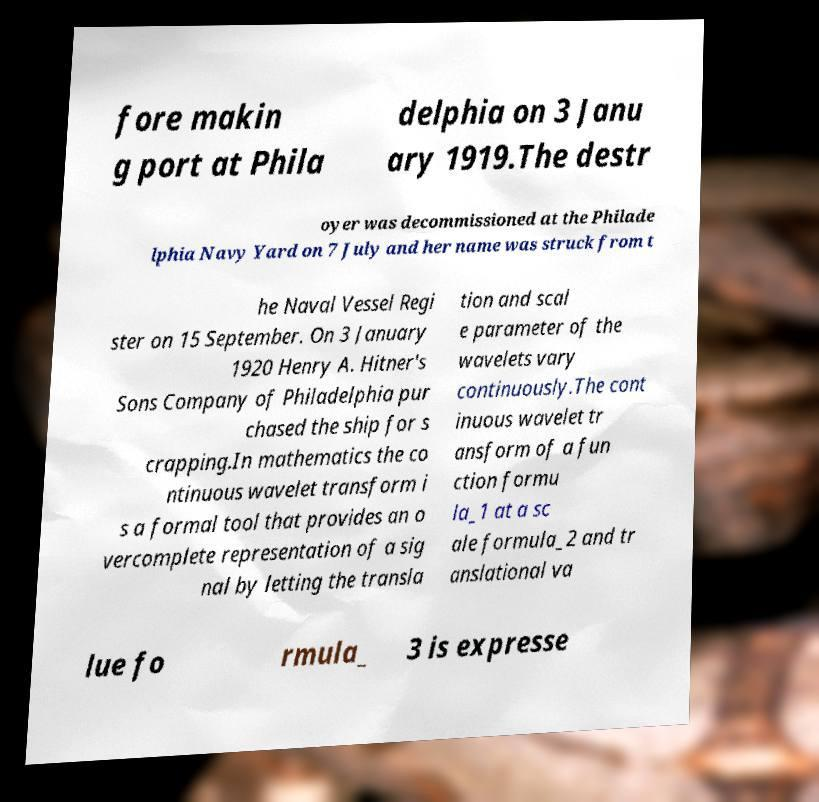What messages or text are displayed in this image? I need them in a readable, typed format. fore makin g port at Phila delphia on 3 Janu ary 1919.The destr oyer was decommissioned at the Philade lphia Navy Yard on 7 July and her name was struck from t he Naval Vessel Regi ster on 15 September. On 3 January 1920 Henry A. Hitner's Sons Company of Philadelphia pur chased the ship for s crapping.In mathematics the co ntinuous wavelet transform i s a formal tool that provides an o vercomplete representation of a sig nal by letting the transla tion and scal e parameter of the wavelets vary continuously.The cont inuous wavelet tr ansform of a fun ction formu la_1 at a sc ale formula_2 and tr anslational va lue fo rmula_ 3 is expresse 